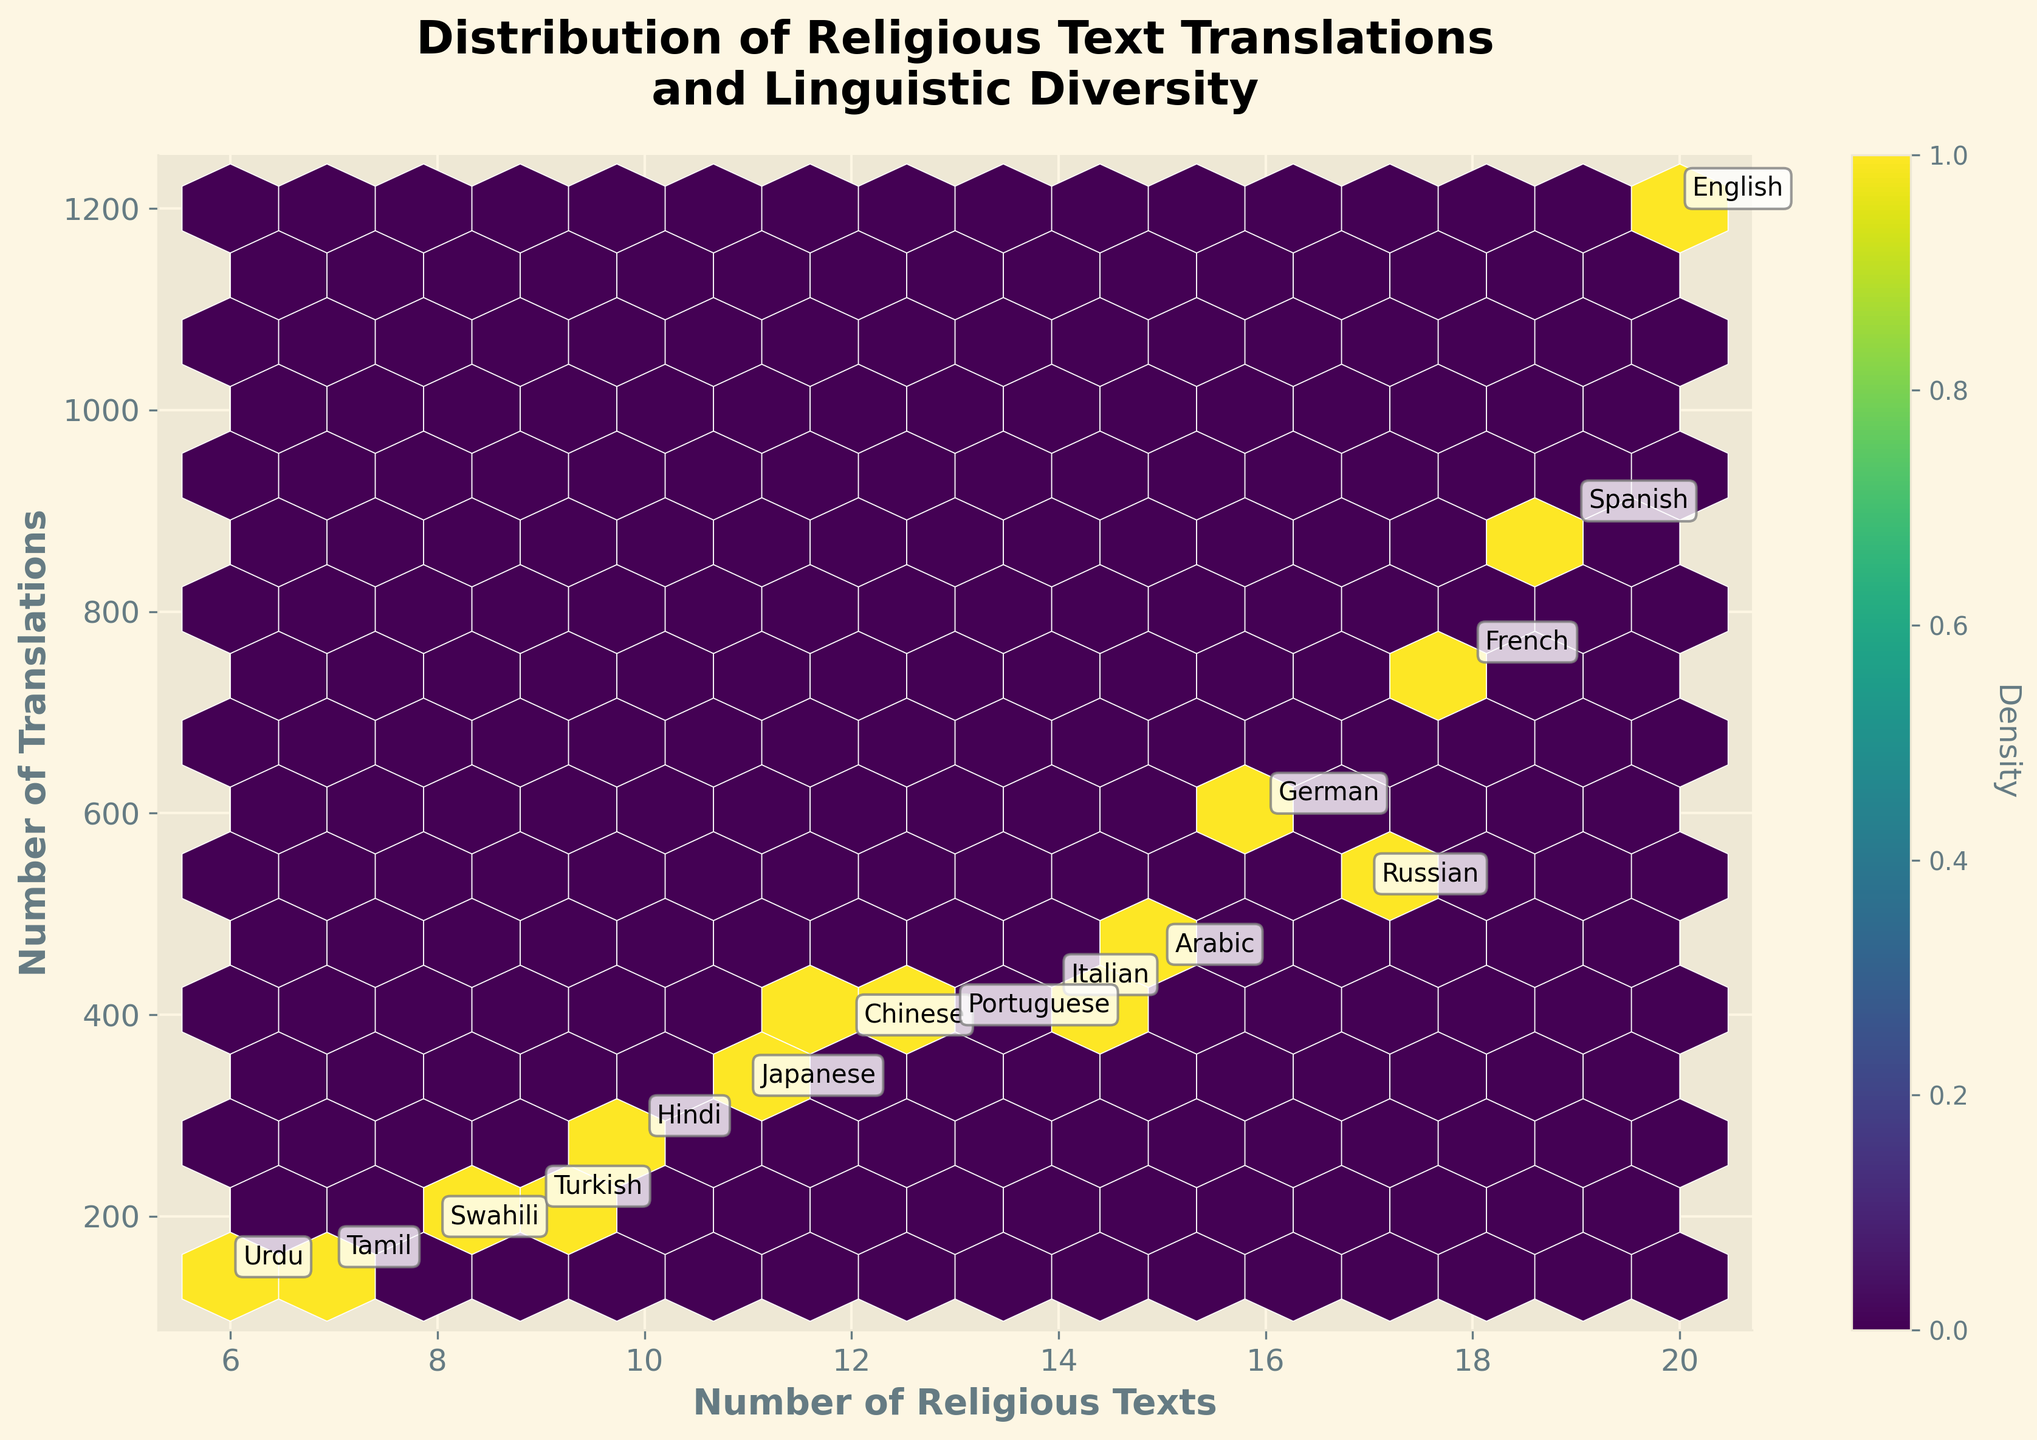What is the title of the plot? The title is located at the top of the plot, usually centered and in bold font. It summarises what the plot is about.
Answer: Distribution of Religious Text Translations and Linguistic Diversity How many languages have more than 15 religious texts? By examining the plot, we identify data points for languages with more than 15 religious texts and count them.
Answer: 4 Which language has the highest number of translations? Look for the data point annotated with the highest translation value along the y-axis, and note the associated language.
Answer: English What number of religious texts corresponds to approximately 600 translations? Identify the relevant y-axis value (approx. 600) and trace horizontally to see which data point corresponds in terms of religious texts.
Answer: German Which has more translations, the language with 10 religious texts or the one with 9? Compare the translations (y-axis values) for the data points where the x-axis values are 10 and 9.
Answer: 10 religious texts (Hindi) What is the average number of translations for languages with fewer than 10 religious texts? Identify languages with fewer than 10 religious texts, sum their translations, and divide by the count of these languages. Total translations for these languages are 180 (Swahili) + 150 (Tamil) + 140 (Urdu) + 210 (Turkish). Thus, (180 + 150 + 140 + 210) / 4 = 680 / 4.
Answer: 170 Which languages are denser in terms of data points in the hexbin plot? Identify large clusters in the hexbin plot by noting the color gradient representing data density.
Answer: Languages with 10-14 religious texts and 250-450 translations How many languages have fewer than 200 translations? Count the data points where the y-axis (translations) value is below 200.
Answer: 3 Is there a correlation between the number of religious texts and translations? Observe the overall direction and spread of the plot points and whether there’s a noticeable pattern trend (e.g., upward slope).
Answer: Yes, positive correlation Which language with exactly 12 religious texts has the most translations? Identify data points on the x-axis corresponding to 12 religious texts and compare the y-axis (translation) values.
Answer: Chinese 